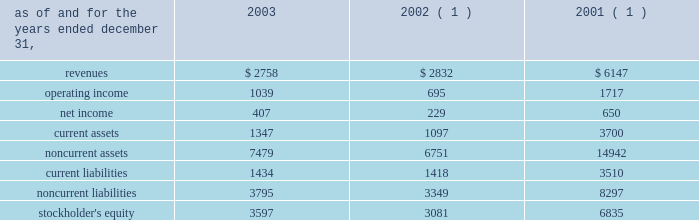In the fourth quarter of 2002 , aes lost voting control of one of the holding companies in the cemig ownership structure .
This holding company indirectly owns the shares related to the cemig investment and indirectly holds the project financing debt related to cemig .
As a result of the loss of voting control , aes stopped consolidating this holding company at december 31 , 2002 .
Other .
During the fourth quarter of 2003 , the company sold its 25% ( 25 % ) ownership interest in medway power limited ( 2018 2018mpl 2019 2019 ) , a 688 mw natural gas-fired combined cycle facility located in the united kingdom , and aes medway operations limited ( 2018 2018aesmo 2019 2019 ) , the operating company for the facility , in an aggregate transaction valued at approximately a347 million ( $ 78 million ) .
The sale resulted in a gain of $ 23 million which was recorded in continuing operations .
Mpl and aesmo were previously reported in the contract generation segment .
In the second quarter of 2002 , the company sold its investment in empresa de infovias s.a .
( 2018 2018infovias 2019 2019 ) , a telecommunications company in brazil , for proceeds of $ 31 million to cemig , an affiliated company .
The loss recorded on the sale was approximately $ 14 million and is recorded as a loss on sale of assets and asset impairment expenses in the accompanying consolidated statements of operations .
In the second quarter of 2002 , the company recorded an impairment charge of approximately $ 40 million , after income taxes , on an equity method investment in a telecommunications company in latin america held by edc .
The impairment charge resulted from sustained poor operating performance coupled with recent funding problems at the invested company .
During 2001 , the company lost operational control of central electricity supply corporation ( 2018 2018cesco 2019 2019 ) , a distribution company located in the state of orissa , india .
The state of orissa appointed an administrator to take operational control of cesco .
Cesco is accounted for as a cost method investment .
Aes 2019s investment in cesco is negative .
In august 2000 , a subsidiary of the company acquired a 49% ( 49 % ) interest in songas for approximately $ 40 million .
The company acquired an additional 16.79% ( 16.79 % ) of songas for approximately $ 12.5 million , and the company began consolidating this entity in 2002 .
Songas owns the songo songo gas-to-electricity project in tanzania .
In december 2002 , the company signed a sales purchase agreement to sell 100% ( 100 % ) of our ownership interest in songas .
The sale of songas closed in april 2003 ( see note 4 for further discussion of the transaction ) .
The tables present summarized comparative financial information ( in millions ) of the entities in which the company has the ability to exercise significant influence but does not control and that are accounted for using the equity method. .
( 1 ) includes information pertaining to eletropaulo and light prior to february 2002 .
In 2002 and 2001 , the results of operations and the financial position of cemig were negatively impacted by the devaluation of the brazilian real and the impairment charge recorded in 2002 .
The brazilian real devalued 32% ( 32 % ) and 19% ( 19 % ) for the years ended december 31 , 2002 and 2001 , respectively. .
What was the percentage change in operating income for entities in which the company has the ability to exercise significant influence but does not control and that are accounted for using the equity method between 2002 and 2003? 
Computations: ((1039 - 695) / 695)
Answer: 0.49496. 